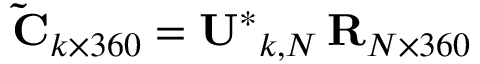<formula> <loc_0><loc_0><loc_500><loc_500>\tilde { C } _ { k \times 3 6 0 } = U ^ { * } _ { k , N } \, R _ { N \times 3 6 0 }</formula> 